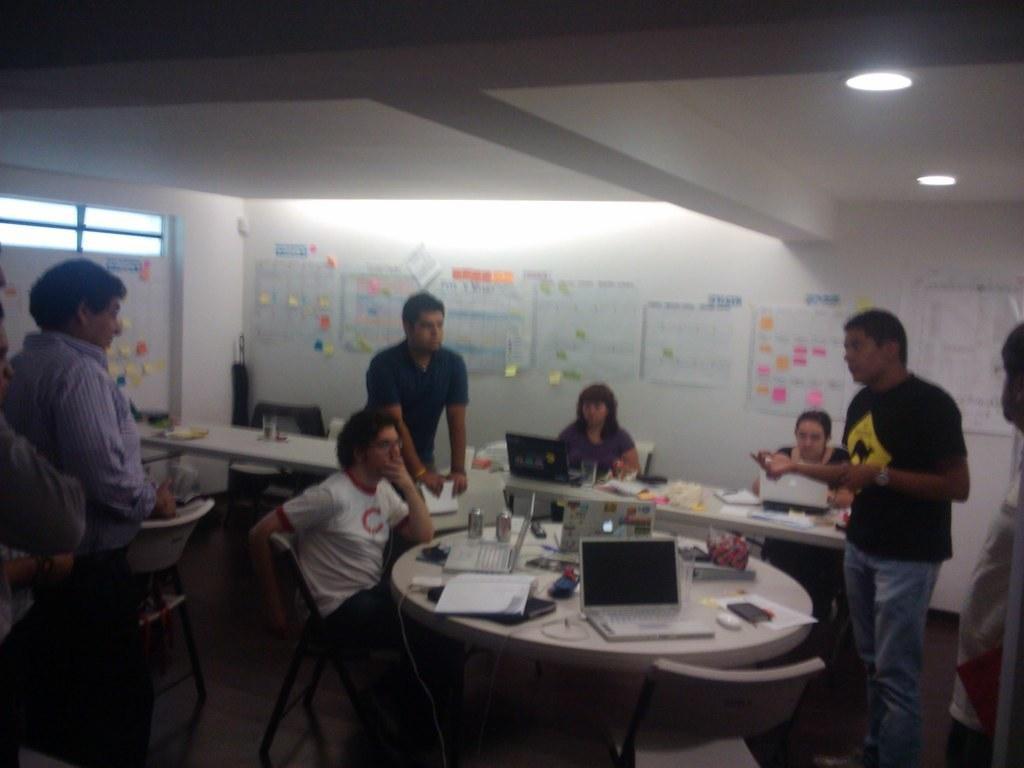Could you give a brief overview of what you see in this image? In this image I can see the group of people with different colored dressers. I can see few people are sitting in-front of the table and few people are standing. On the tables I can see the books, laptops, tins, papers and many objects. In the background I can see some papers to the wall. And there are lights in the top. 